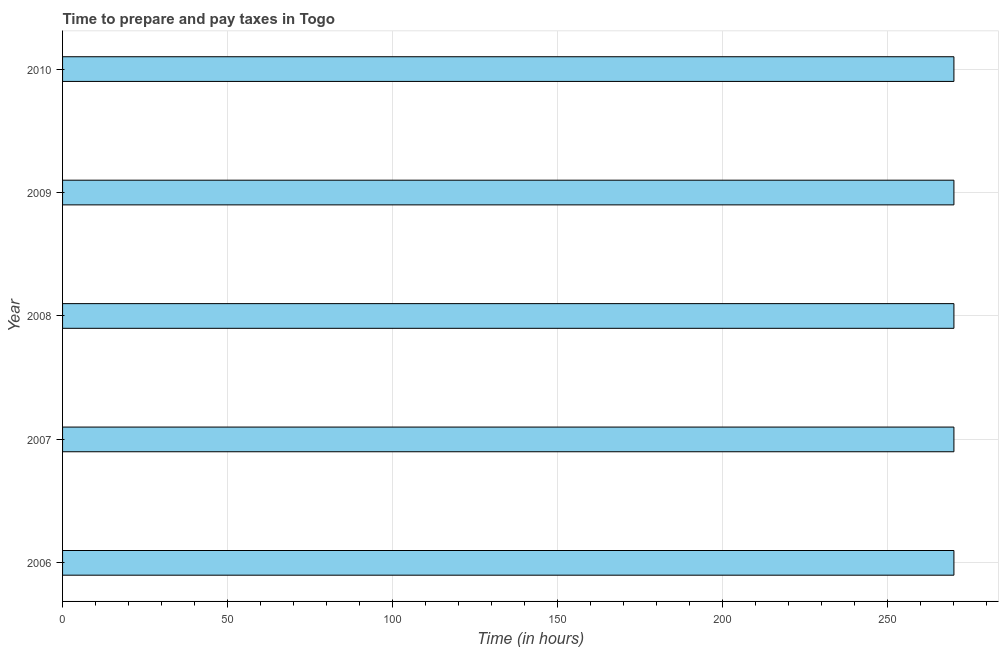Does the graph contain any zero values?
Provide a short and direct response. No. What is the title of the graph?
Keep it short and to the point. Time to prepare and pay taxes in Togo. What is the label or title of the X-axis?
Your answer should be compact. Time (in hours). What is the label or title of the Y-axis?
Make the answer very short. Year. What is the time to prepare and pay taxes in 2006?
Keep it short and to the point. 270. Across all years, what is the maximum time to prepare and pay taxes?
Provide a short and direct response. 270. Across all years, what is the minimum time to prepare and pay taxes?
Give a very brief answer. 270. In which year was the time to prepare and pay taxes maximum?
Your response must be concise. 2006. What is the sum of the time to prepare and pay taxes?
Make the answer very short. 1350. What is the average time to prepare and pay taxes per year?
Make the answer very short. 270. What is the median time to prepare and pay taxes?
Give a very brief answer. 270. What is the ratio of the time to prepare and pay taxes in 2006 to that in 2009?
Your answer should be compact. 1. What is the difference between the highest and the second highest time to prepare and pay taxes?
Give a very brief answer. 0. What is the difference between the highest and the lowest time to prepare and pay taxes?
Give a very brief answer. 0. Are all the bars in the graph horizontal?
Provide a succinct answer. Yes. How many years are there in the graph?
Ensure brevity in your answer.  5. What is the difference between two consecutive major ticks on the X-axis?
Give a very brief answer. 50. Are the values on the major ticks of X-axis written in scientific E-notation?
Make the answer very short. No. What is the Time (in hours) of 2006?
Keep it short and to the point. 270. What is the Time (in hours) of 2007?
Your answer should be compact. 270. What is the Time (in hours) of 2008?
Provide a short and direct response. 270. What is the Time (in hours) of 2009?
Offer a terse response. 270. What is the Time (in hours) in 2010?
Offer a very short reply. 270. What is the difference between the Time (in hours) in 2006 and 2007?
Ensure brevity in your answer.  0. What is the difference between the Time (in hours) in 2006 and 2009?
Ensure brevity in your answer.  0. What is the difference between the Time (in hours) in 2007 and 2010?
Provide a short and direct response. 0. What is the difference between the Time (in hours) in 2008 and 2009?
Give a very brief answer. 0. What is the difference between the Time (in hours) in 2008 and 2010?
Give a very brief answer. 0. What is the difference between the Time (in hours) in 2009 and 2010?
Your response must be concise. 0. What is the ratio of the Time (in hours) in 2006 to that in 2007?
Give a very brief answer. 1. What is the ratio of the Time (in hours) in 2006 to that in 2008?
Offer a terse response. 1. What is the ratio of the Time (in hours) in 2006 to that in 2009?
Your response must be concise. 1. What is the ratio of the Time (in hours) in 2006 to that in 2010?
Your answer should be very brief. 1. What is the ratio of the Time (in hours) in 2009 to that in 2010?
Your answer should be compact. 1. 